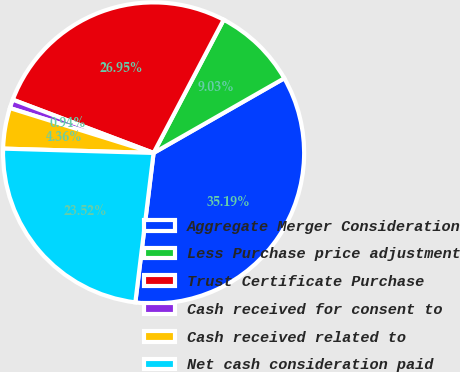<chart> <loc_0><loc_0><loc_500><loc_500><pie_chart><fcel>Aggregate Merger Consideration<fcel>Less Purchase price adjustment<fcel>Trust Certificate Purchase<fcel>Cash received for consent to<fcel>Cash received related to<fcel>Net cash consideration paid<nl><fcel>35.19%<fcel>9.03%<fcel>26.95%<fcel>0.94%<fcel>4.36%<fcel>23.52%<nl></chart> 